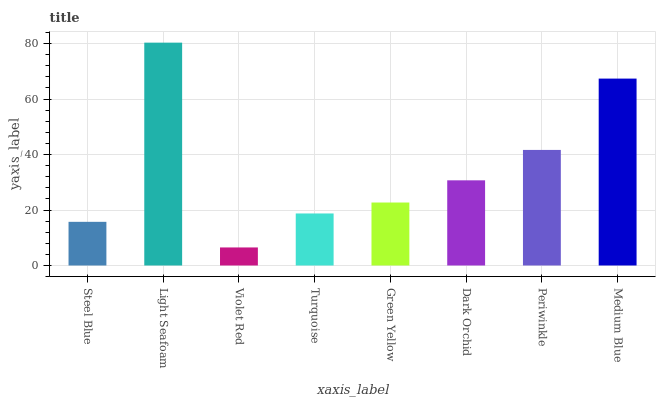Is Light Seafoam the minimum?
Answer yes or no. No. Is Violet Red the maximum?
Answer yes or no. No. Is Light Seafoam greater than Violet Red?
Answer yes or no. Yes. Is Violet Red less than Light Seafoam?
Answer yes or no. Yes. Is Violet Red greater than Light Seafoam?
Answer yes or no. No. Is Light Seafoam less than Violet Red?
Answer yes or no. No. Is Dark Orchid the high median?
Answer yes or no. Yes. Is Green Yellow the low median?
Answer yes or no. Yes. Is Turquoise the high median?
Answer yes or no. No. Is Light Seafoam the low median?
Answer yes or no. No. 